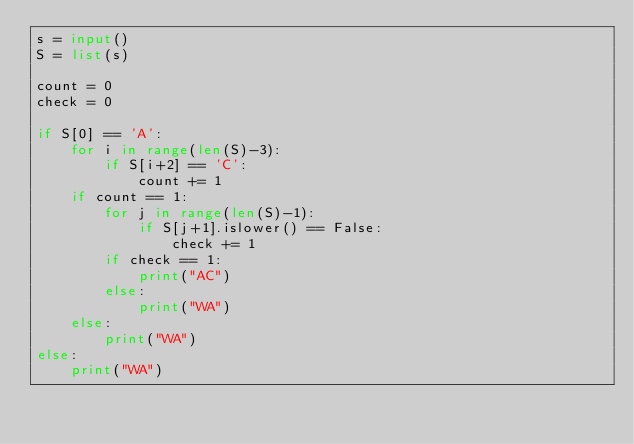<code> <loc_0><loc_0><loc_500><loc_500><_Python_>s = input()
S = list(s)

count = 0
check = 0

if S[0] == 'A':
    for i in range(len(S)-3):
        if S[i+2] == 'C':
            count += 1
    if count == 1:
        for j in range(len(S)-1):
            if S[j+1].islower() == False:
                check += 1
        if check == 1:
            print("AC")
        else:
            print("WA")
    else:
        print("WA")
else:
    print("WA")</code> 